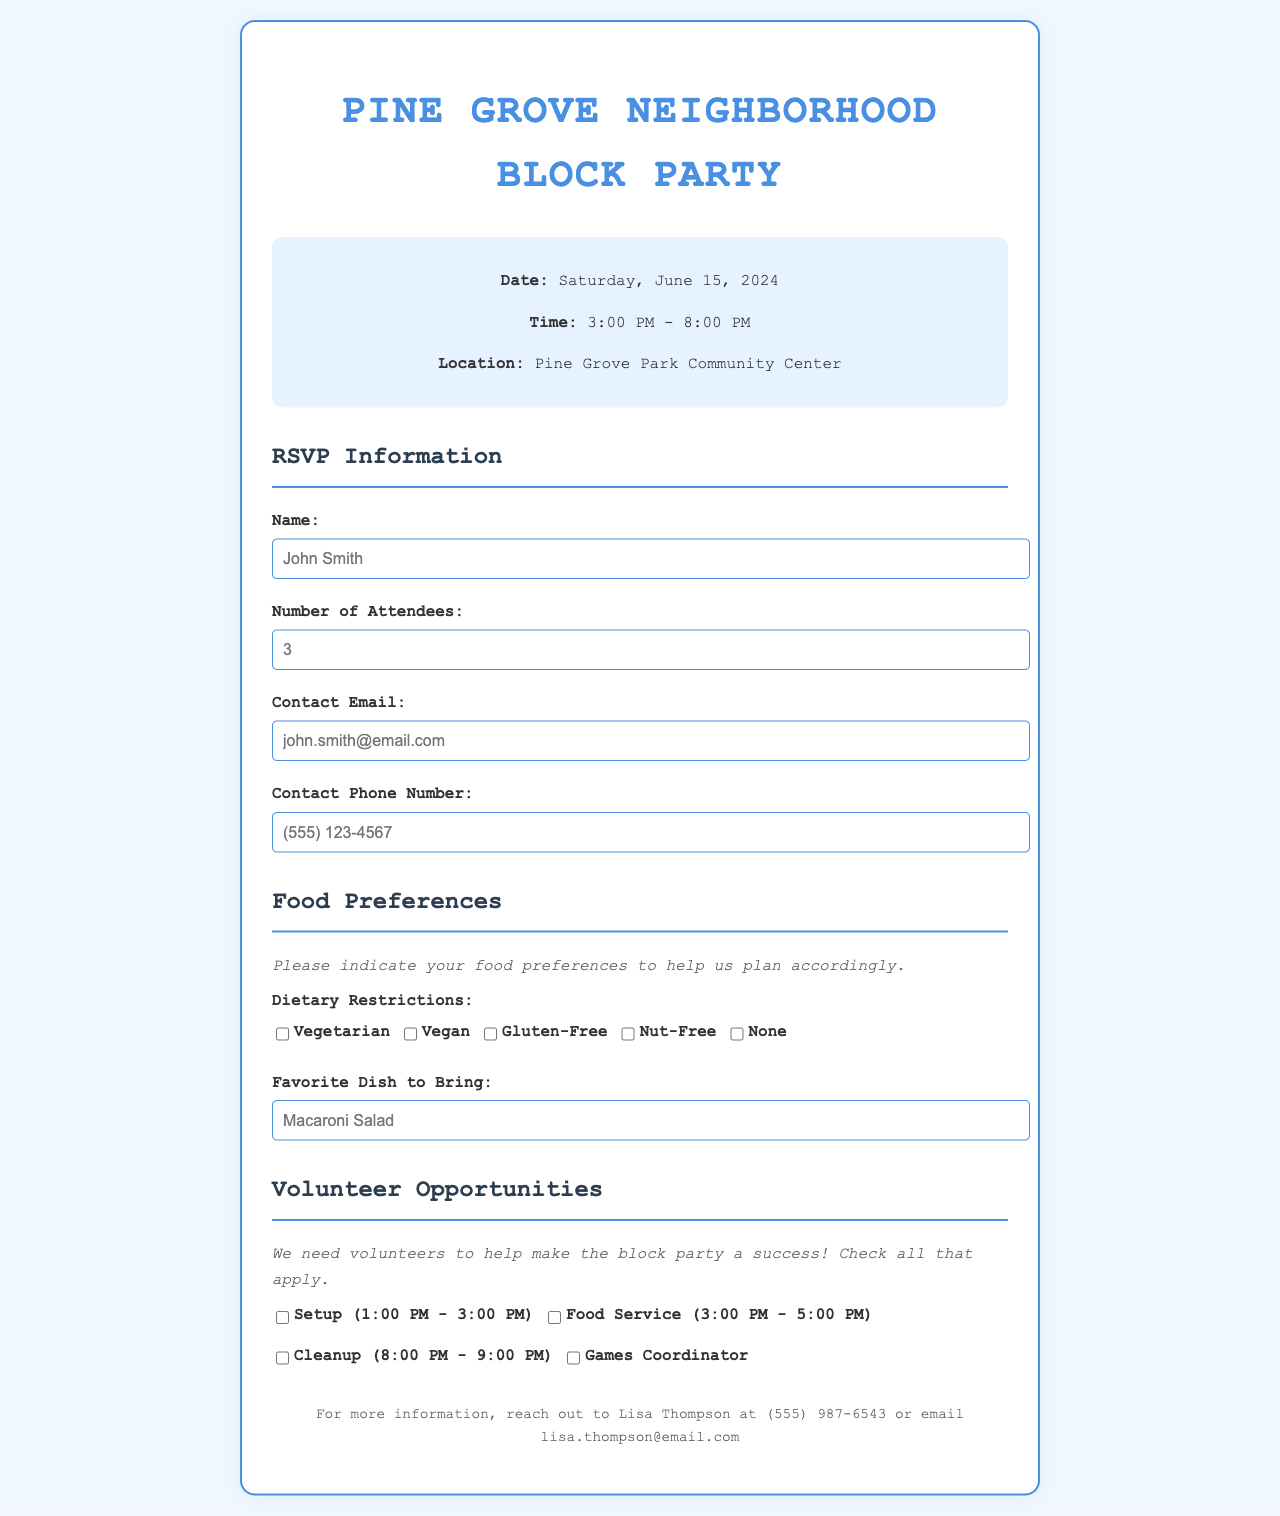What is the date of the event? The document states that the block party is scheduled for Saturday, June 15, 2024.
Answer: Saturday, June 15, 2024 What time does the event start? The document specifies the starting time of the block party as 3:00 PM.
Answer: 3:00 PM Who should be contacted for more information? The footer of the document mentions Lisa Thompson as the contact person for more information.
Answer: Lisa Thompson What is the location of the event? According to the document, the block party will take place at Pine Grove Park Community Center.
Answer: Pine Grove Park Community Center How many people can be included in the RSVP? The RSVP section allows the user to enter the number of attendees, which is a number input.
Answer: Any number What options are available for dietary restrictions? The document lists vegetarian, vegan, gluten-free, nut-free, and none as dietary restriction options.
Answer: Vegetarian, vegan, gluten-free, nut-free, none What is the time frame for setup volunteers? The document mentions that setup volunteers are needed from 1:00 PM to 3:00 PM.
Answer: 1:00 PM - 3:00 PM What favorite dish is suggested to bring? The form includes an input for a favorite dish to bring, provided as a short text entry.
Answer: Any dish Which role is likely to have the latest finishing time? The cleanup role is stated to be from 8:00 PM to 9:00 PM, making it the last to finish.
Answer: Cleanup 